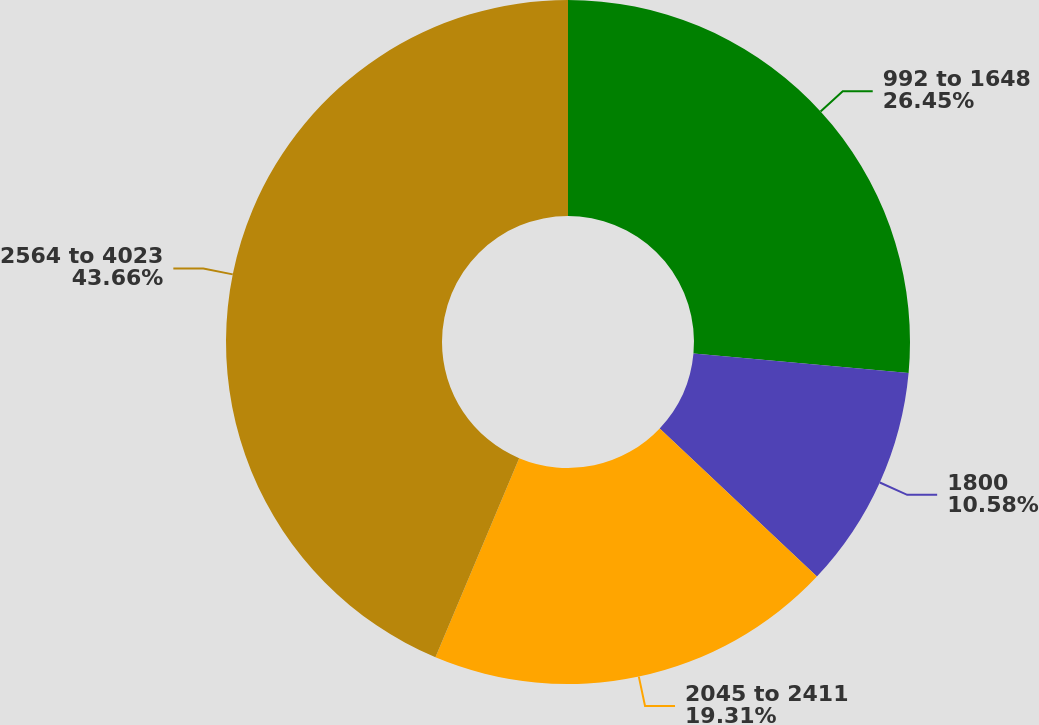Convert chart. <chart><loc_0><loc_0><loc_500><loc_500><pie_chart><fcel>992 to 1648<fcel>1800<fcel>2045 to 2411<fcel>2564 to 4023<nl><fcel>26.45%<fcel>10.58%<fcel>19.31%<fcel>43.67%<nl></chart> 